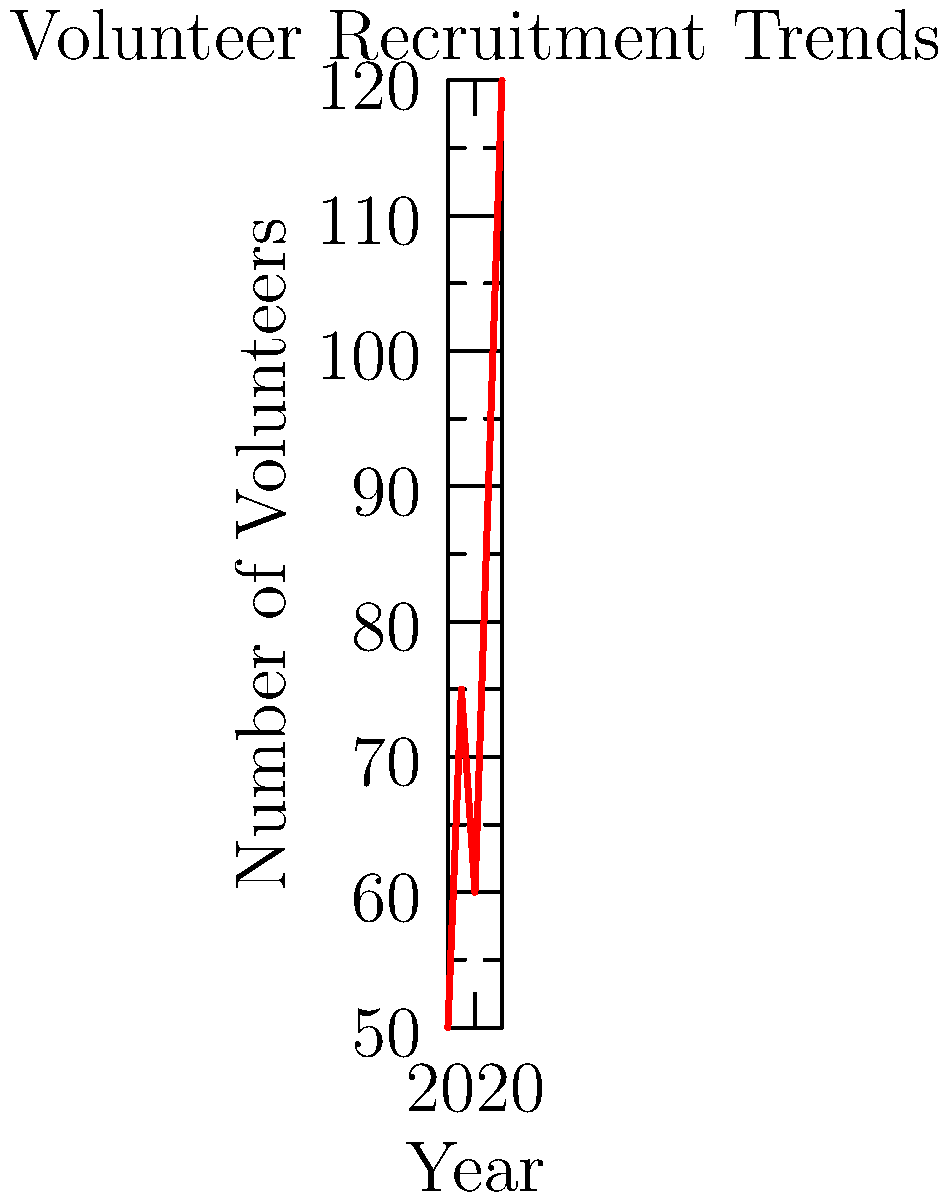Based on the line graph showing volunteer recruitment trends from 2018 to 2022, what was the percentage increase in the number of volunteers from 2021 to 2022? To calculate the percentage increase in volunteers from 2021 to 2022, we need to follow these steps:

1. Identify the number of volunteers in 2021 and 2022:
   2021: 90 volunteers
   2022: 120 volunteers

2. Calculate the difference in volunteers:
   120 - 90 = 30 volunteers

3. Calculate the percentage increase:
   Percentage increase = (Increase / Original Number) × 100
   = (30 / 90) × 100
   = 0.3333... × 100
   = 33.33%

Therefore, the percentage increase in the number of volunteers from 2021 to 2022 was approximately 33.33%.
Answer: 33.33% 